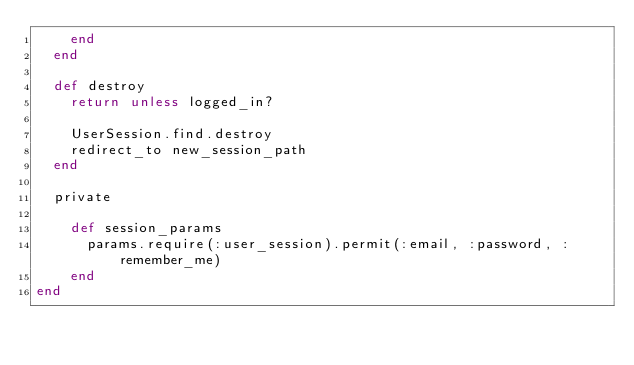<code> <loc_0><loc_0><loc_500><loc_500><_Ruby_>    end
  end

  def destroy
    return unless logged_in?

    UserSession.find.destroy
    redirect_to new_session_path
  end

  private

    def session_params
      params.require(:user_session).permit(:email, :password, :remember_me)
    end
end
</code> 